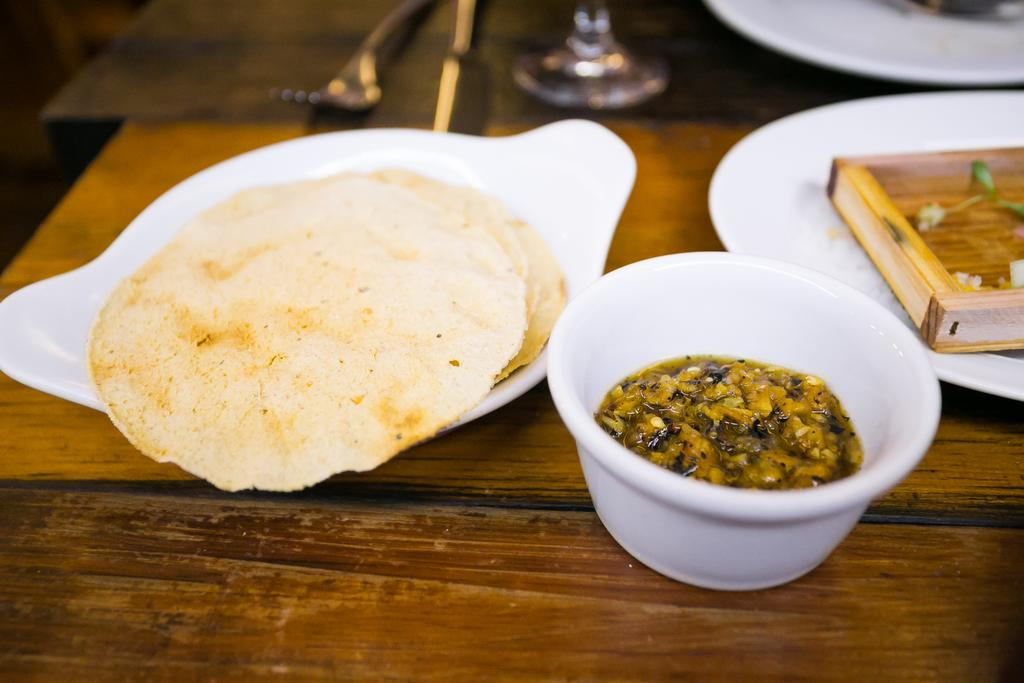What type of furniture is present in the image? There is a table in the image. What can be found on the table? There is cutlery, crochets, food in plates, and food in bowls on the table. How is the food being served on the table? The food is being served in plates and bowls on the table. What type of oil is being used to cook the food in the image? There is no indication of any cooking or oil in the image; it only shows food in plates and bowls on a table. 